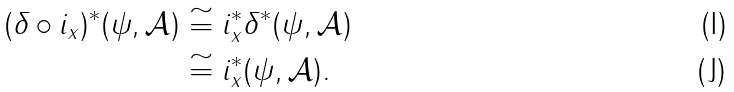<formula> <loc_0><loc_0><loc_500><loc_500>( \delta \circ i _ { x } ) ^ { * } ( \psi , \mathcal { A } ) & \cong i _ { x } ^ { * } \delta ^ { * } ( \psi , \mathcal { A } ) \\ & \cong i _ { x } ^ { * } ( \psi , \mathcal { A } ) .</formula> 